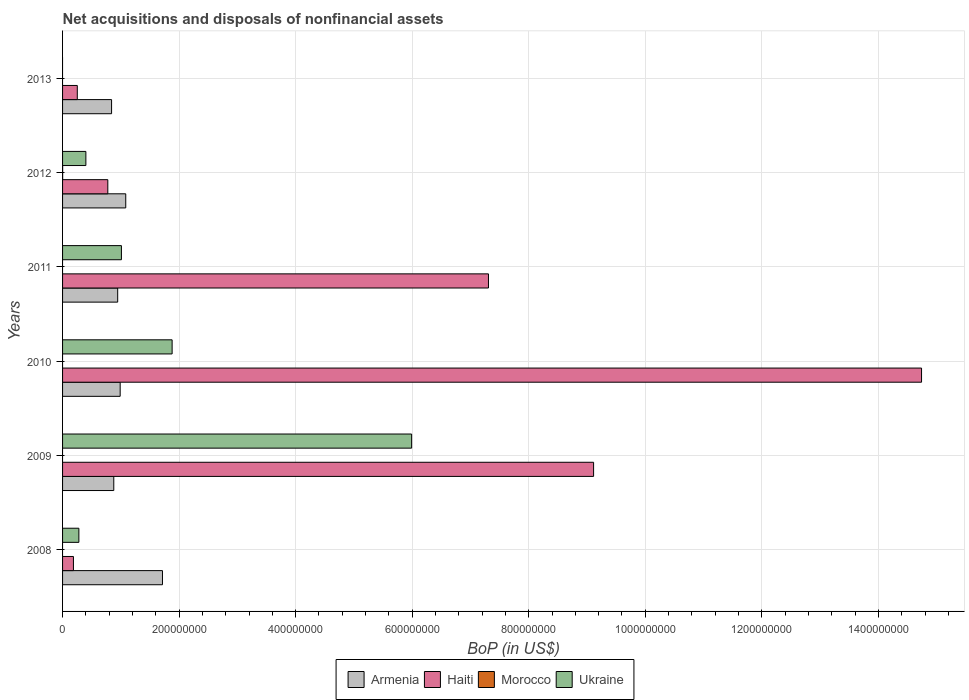Are the number of bars on each tick of the Y-axis equal?
Provide a short and direct response. No. What is the label of the 5th group of bars from the top?
Provide a succinct answer. 2009. What is the Balance of Payments in Haiti in 2012?
Your answer should be very brief. 7.77e+07. Across all years, what is the maximum Balance of Payments in Haiti?
Offer a terse response. 1.47e+09. Across all years, what is the minimum Balance of Payments in Armenia?
Offer a very short reply. 8.41e+07. In which year was the Balance of Payments in Armenia maximum?
Your answer should be compact. 2008. What is the total Balance of Payments in Ukraine in the graph?
Offer a very short reply. 9.56e+08. What is the difference between the Balance of Payments in Ukraine in 2008 and that in 2012?
Offer a very short reply. -1.20e+07. What is the difference between the Balance of Payments in Armenia in 2010 and the Balance of Payments in Ukraine in 2009?
Your response must be concise. -5.00e+08. What is the average Balance of Payments in Morocco per year?
Your answer should be compact. 2.14e+04. In the year 2008, what is the difference between the Balance of Payments in Haiti and Balance of Payments in Armenia?
Make the answer very short. -1.53e+08. What is the ratio of the Balance of Payments in Haiti in 2010 to that in 2012?
Make the answer very short. 18.98. Is the Balance of Payments in Haiti in 2011 less than that in 2013?
Offer a terse response. No. What is the difference between the highest and the second highest Balance of Payments in Haiti?
Ensure brevity in your answer.  5.63e+08. What is the difference between the highest and the lowest Balance of Payments in Morocco?
Your answer should be compact. 1.28e+05. In how many years, is the Balance of Payments in Ukraine greater than the average Balance of Payments in Ukraine taken over all years?
Ensure brevity in your answer.  2. Is the sum of the Balance of Payments in Ukraine in 2008 and 2012 greater than the maximum Balance of Payments in Morocco across all years?
Provide a short and direct response. Yes. Is it the case that in every year, the sum of the Balance of Payments in Haiti and Balance of Payments in Morocco is greater than the Balance of Payments in Ukraine?
Provide a succinct answer. No. Are all the bars in the graph horizontal?
Make the answer very short. Yes. Does the graph contain any zero values?
Your answer should be very brief. Yes. Where does the legend appear in the graph?
Your answer should be compact. Bottom center. How many legend labels are there?
Offer a terse response. 4. How are the legend labels stacked?
Keep it short and to the point. Horizontal. What is the title of the graph?
Offer a very short reply. Net acquisitions and disposals of nonfinancial assets. What is the label or title of the X-axis?
Provide a succinct answer. BoP (in US$). What is the BoP (in US$) of Armenia in 2008?
Your answer should be compact. 1.71e+08. What is the BoP (in US$) of Haiti in 2008?
Your answer should be very brief. 1.87e+07. What is the BoP (in US$) of Morocco in 2008?
Provide a succinct answer. 0. What is the BoP (in US$) of Ukraine in 2008?
Provide a succinct answer. 2.80e+07. What is the BoP (in US$) in Armenia in 2009?
Ensure brevity in your answer.  8.79e+07. What is the BoP (in US$) in Haiti in 2009?
Your response must be concise. 9.11e+08. What is the BoP (in US$) of Ukraine in 2009?
Your answer should be compact. 5.99e+08. What is the BoP (in US$) in Armenia in 2010?
Keep it short and to the point. 9.89e+07. What is the BoP (in US$) of Haiti in 2010?
Ensure brevity in your answer.  1.47e+09. What is the BoP (in US$) of Ukraine in 2010?
Provide a succinct answer. 1.88e+08. What is the BoP (in US$) in Armenia in 2011?
Your response must be concise. 9.46e+07. What is the BoP (in US$) of Haiti in 2011?
Make the answer very short. 7.31e+08. What is the BoP (in US$) in Ukraine in 2011?
Your response must be concise. 1.01e+08. What is the BoP (in US$) in Armenia in 2012?
Make the answer very short. 1.08e+08. What is the BoP (in US$) in Haiti in 2012?
Offer a terse response. 7.77e+07. What is the BoP (in US$) in Morocco in 2012?
Your answer should be very brief. 1.28e+05. What is the BoP (in US$) in Ukraine in 2012?
Give a very brief answer. 4.00e+07. What is the BoP (in US$) of Armenia in 2013?
Keep it short and to the point. 8.41e+07. What is the BoP (in US$) in Haiti in 2013?
Your response must be concise. 2.53e+07. Across all years, what is the maximum BoP (in US$) of Armenia?
Make the answer very short. 1.71e+08. Across all years, what is the maximum BoP (in US$) in Haiti?
Keep it short and to the point. 1.47e+09. Across all years, what is the maximum BoP (in US$) in Morocco?
Offer a very short reply. 1.28e+05. Across all years, what is the maximum BoP (in US$) in Ukraine?
Offer a terse response. 5.99e+08. Across all years, what is the minimum BoP (in US$) in Armenia?
Make the answer very short. 8.41e+07. Across all years, what is the minimum BoP (in US$) in Haiti?
Provide a short and direct response. 1.87e+07. Across all years, what is the minimum BoP (in US$) in Morocco?
Keep it short and to the point. 0. What is the total BoP (in US$) in Armenia in the graph?
Your answer should be compact. 6.45e+08. What is the total BoP (in US$) in Haiti in the graph?
Give a very brief answer. 3.24e+09. What is the total BoP (in US$) of Morocco in the graph?
Make the answer very short. 1.28e+05. What is the total BoP (in US$) of Ukraine in the graph?
Make the answer very short. 9.56e+08. What is the difference between the BoP (in US$) in Armenia in 2008 and that in 2009?
Provide a succinct answer. 8.36e+07. What is the difference between the BoP (in US$) in Haiti in 2008 and that in 2009?
Your answer should be very brief. -8.93e+08. What is the difference between the BoP (in US$) in Ukraine in 2008 and that in 2009?
Ensure brevity in your answer.  -5.71e+08. What is the difference between the BoP (in US$) of Armenia in 2008 and that in 2010?
Your answer should be very brief. 7.26e+07. What is the difference between the BoP (in US$) of Haiti in 2008 and that in 2010?
Keep it short and to the point. -1.46e+09. What is the difference between the BoP (in US$) in Ukraine in 2008 and that in 2010?
Give a very brief answer. -1.60e+08. What is the difference between the BoP (in US$) of Armenia in 2008 and that in 2011?
Keep it short and to the point. 7.68e+07. What is the difference between the BoP (in US$) in Haiti in 2008 and that in 2011?
Give a very brief answer. -7.12e+08. What is the difference between the BoP (in US$) of Ukraine in 2008 and that in 2011?
Offer a very short reply. -7.30e+07. What is the difference between the BoP (in US$) of Armenia in 2008 and that in 2012?
Provide a short and direct response. 6.30e+07. What is the difference between the BoP (in US$) in Haiti in 2008 and that in 2012?
Give a very brief answer. -5.90e+07. What is the difference between the BoP (in US$) in Ukraine in 2008 and that in 2012?
Make the answer very short. -1.20e+07. What is the difference between the BoP (in US$) of Armenia in 2008 and that in 2013?
Your response must be concise. 8.73e+07. What is the difference between the BoP (in US$) in Haiti in 2008 and that in 2013?
Keep it short and to the point. -6.62e+06. What is the difference between the BoP (in US$) of Armenia in 2009 and that in 2010?
Provide a succinct answer. -1.10e+07. What is the difference between the BoP (in US$) in Haiti in 2009 and that in 2010?
Offer a very short reply. -5.63e+08. What is the difference between the BoP (in US$) of Ukraine in 2009 and that in 2010?
Offer a terse response. 4.11e+08. What is the difference between the BoP (in US$) of Armenia in 2009 and that in 2011?
Make the answer very short. -6.72e+06. What is the difference between the BoP (in US$) in Haiti in 2009 and that in 2011?
Make the answer very short. 1.80e+08. What is the difference between the BoP (in US$) of Ukraine in 2009 and that in 2011?
Your response must be concise. 4.98e+08. What is the difference between the BoP (in US$) in Armenia in 2009 and that in 2012?
Offer a terse response. -2.05e+07. What is the difference between the BoP (in US$) of Haiti in 2009 and that in 2012?
Keep it short and to the point. 8.34e+08. What is the difference between the BoP (in US$) in Ukraine in 2009 and that in 2012?
Offer a very short reply. 5.59e+08. What is the difference between the BoP (in US$) in Armenia in 2009 and that in 2013?
Make the answer very short. 3.76e+06. What is the difference between the BoP (in US$) of Haiti in 2009 and that in 2013?
Ensure brevity in your answer.  8.86e+08. What is the difference between the BoP (in US$) of Armenia in 2010 and that in 2011?
Give a very brief answer. 4.26e+06. What is the difference between the BoP (in US$) of Haiti in 2010 and that in 2011?
Give a very brief answer. 7.43e+08. What is the difference between the BoP (in US$) in Ukraine in 2010 and that in 2011?
Offer a very short reply. 8.70e+07. What is the difference between the BoP (in US$) in Armenia in 2010 and that in 2012?
Offer a very short reply. -9.55e+06. What is the difference between the BoP (in US$) in Haiti in 2010 and that in 2012?
Keep it short and to the point. 1.40e+09. What is the difference between the BoP (in US$) of Ukraine in 2010 and that in 2012?
Give a very brief answer. 1.48e+08. What is the difference between the BoP (in US$) of Armenia in 2010 and that in 2013?
Make the answer very short. 1.47e+07. What is the difference between the BoP (in US$) in Haiti in 2010 and that in 2013?
Provide a succinct answer. 1.45e+09. What is the difference between the BoP (in US$) of Armenia in 2011 and that in 2012?
Ensure brevity in your answer.  -1.38e+07. What is the difference between the BoP (in US$) of Haiti in 2011 and that in 2012?
Make the answer very short. 6.53e+08. What is the difference between the BoP (in US$) of Ukraine in 2011 and that in 2012?
Your response must be concise. 6.10e+07. What is the difference between the BoP (in US$) in Armenia in 2011 and that in 2013?
Provide a short and direct response. 1.05e+07. What is the difference between the BoP (in US$) in Haiti in 2011 and that in 2013?
Provide a short and direct response. 7.06e+08. What is the difference between the BoP (in US$) of Armenia in 2012 and that in 2013?
Give a very brief answer. 2.43e+07. What is the difference between the BoP (in US$) in Haiti in 2012 and that in 2013?
Your response must be concise. 5.24e+07. What is the difference between the BoP (in US$) of Armenia in 2008 and the BoP (in US$) of Haiti in 2009?
Provide a succinct answer. -7.40e+08. What is the difference between the BoP (in US$) of Armenia in 2008 and the BoP (in US$) of Ukraine in 2009?
Provide a succinct answer. -4.28e+08. What is the difference between the BoP (in US$) of Haiti in 2008 and the BoP (in US$) of Ukraine in 2009?
Offer a terse response. -5.80e+08. What is the difference between the BoP (in US$) in Armenia in 2008 and the BoP (in US$) in Haiti in 2010?
Your response must be concise. -1.30e+09. What is the difference between the BoP (in US$) in Armenia in 2008 and the BoP (in US$) in Ukraine in 2010?
Give a very brief answer. -1.66e+07. What is the difference between the BoP (in US$) in Haiti in 2008 and the BoP (in US$) in Ukraine in 2010?
Offer a terse response. -1.69e+08. What is the difference between the BoP (in US$) in Armenia in 2008 and the BoP (in US$) in Haiti in 2011?
Give a very brief answer. -5.59e+08. What is the difference between the BoP (in US$) in Armenia in 2008 and the BoP (in US$) in Ukraine in 2011?
Your answer should be very brief. 7.04e+07. What is the difference between the BoP (in US$) of Haiti in 2008 and the BoP (in US$) of Ukraine in 2011?
Your answer should be compact. -8.23e+07. What is the difference between the BoP (in US$) in Armenia in 2008 and the BoP (in US$) in Haiti in 2012?
Ensure brevity in your answer.  9.38e+07. What is the difference between the BoP (in US$) of Armenia in 2008 and the BoP (in US$) of Morocco in 2012?
Keep it short and to the point. 1.71e+08. What is the difference between the BoP (in US$) in Armenia in 2008 and the BoP (in US$) in Ukraine in 2012?
Your response must be concise. 1.31e+08. What is the difference between the BoP (in US$) of Haiti in 2008 and the BoP (in US$) of Morocco in 2012?
Ensure brevity in your answer.  1.85e+07. What is the difference between the BoP (in US$) of Haiti in 2008 and the BoP (in US$) of Ukraine in 2012?
Your response must be concise. -2.13e+07. What is the difference between the BoP (in US$) of Armenia in 2008 and the BoP (in US$) of Haiti in 2013?
Offer a very short reply. 1.46e+08. What is the difference between the BoP (in US$) in Armenia in 2009 and the BoP (in US$) in Haiti in 2010?
Provide a short and direct response. -1.39e+09. What is the difference between the BoP (in US$) in Armenia in 2009 and the BoP (in US$) in Ukraine in 2010?
Offer a terse response. -1.00e+08. What is the difference between the BoP (in US$) of Haiti in 2009 and the BoP (in US$) of Ukraine in 2010?
Make the answer very short. 7.23e+08. What is the difference between the BoP (in US$) of Armenia in 2009 and the BoP (in US$) of Haiti in 2011?
Keep it short and to the point. -6.43e+08. What is the difference between the BoP (in US$) of Armenia in 2009 and the BoP (in US$) of Ukraine in 2011?
Offer a terse response. -1.31e+07. What is the difference between the BoP (in US$) of Haiti in 2009 and the BoP (in US$) of Ukraine in 2011?
Your answer should be very brief. 8.10e+08. What is the difference between the BoP (in US$) in Armenia in 2009 and the BoP (in US$) in Haiti in 2012?
Ensure brevity in your answer.  1.02e+07. What is the difference between the BoP (in US$) in Armenia in 2009 and the BoP (in US$) in Morocco in 2012?
Your answer should be very brief. 8.78e+07. What is the difference between the BoP (in US$) in Armenia in 2009 and the BoP (in US$) in Ukraine in 2012?
Your answer should be very brief. 4.79e+07. What is the difference between the BoP (in US$) of Haiti in 2009 and the BoP (in US$) of Morocco in 2012?
Keep it short and to the point. 9.11e+08. What is the difference between the BoP (in US$) of Haiti in 2009 and the BoP (in US$) of Ukraine in 2012?
Your answer should be very brief. 8.71e+08. What is the difference between the BoP (in US$) of Armenia in 2009 and the BoP (in US$) of Haiti in 2013?
Your answer should be very brief. 6.26e+07. What is the difference between the BoP (in US$) in Armenia in 2010 and the BoP (in US$) in Haiti in 2011?
Ensure brevity in your answer.  -6.32e+08. What is the difference between the BoP (in US$) of Armenia in 2010 and the BoP (in US$) of Ukraine in 2011?
Ensure brevity in your answer.  -2.14e+06. What is the difference between the BoP (in US$) in Haiti in 2010 and the BoP (in US$) in Ukraine in 2011?
Offer a very short reply. 1.37e+09. What is the difference between the BoP (in US$) in Armenia in 2010 and the BoP (in US$) in Haiti in 2012?
Keep it short and to the point. 2.12e+07. What is the difference between the BoP (in US$) of Armenia in 2010 and the BoP (in US$) of Morocco in 2012?
Offer a very short reply. 9.87e+07. What is the difference between the BoP (in US$) of Armenia in 2010 and the BoP (in US$) of Ukraine in 2012?
Offer a very short reply. 5.89e+07. What is the difference between the BoP (in US$) in Haiti in 2010 and the BoP (in US$) in Morocco in 2012?
Your response must be concise. 1.47e+09. What is the difference between the BoP (in US$) of Haiti in 2010 and the BoP (in US$) of Ukraine in 2012?
Provide a short and direct response. 1.43e+09. What is the difference between the BoP (in US$) in Armenia in 2010 and the BoP (in US$) in Haiti in 2013?
Offer a very short reply. 7.36e+07. What is the difference between the BoP (in US$) in Armenia in 2011 and the BoP (in US$) in Haiti in 2012?
Give a very brief answer. 1.69e+07. What is the difference between the BoP (in US$) of Armenia in 2011 and the BoP (in US$) of Morocco in 2012?
Make the answer very short. 9.45e+07. What is the difference between the BoP (in US$) of Armenia in 2011 and the BoP (in US$) of Ukraine in 2012?
Give a very brief answer. 5.46e+07. What is the difference between the BoP (in US$) in Haiti in 2011 and the BoP (in US$) in Morocco in 2012?
Your answer should be very brief. 7.31e+08. What is the difference between the BoP (in US$) of Haiti in 2011 and the BoP (in US$) of Ukraine in 2012?
Offer a very short reply. 6.91e+08. What is the difference between the BoP (in US$) of Armenia in 2011 and the BoP (in US$) of Haiti in 2013?
Ensure brevity in your answer.  6.93e+07. What is the difference between the BoP (in US$) in Armenia in 2012 and the BoP (in US$) in Haiti in 2013?
Make the answer very short. 8.31e+07. What is the average BoP (in US$) of Armenia per year?
Offer a terse response. 1.08e+08. What is the average BoP (in US$) in Haiti per year?
Ensure brevity in your answer.  5.40e+08. What is the average BoP (in US$) of Morocco per year?
Keep it short and to the point. 2.14e+04. What is the average BoP (in US$) in Ukraine per year?
Provide a short and direct response. 1.59e+08. In the year 2008, what is the difference between the BoP (in US$) of Armenia and BoP (in US$) of Haiti?
Offer a very short reply. 1.53e+08. In the year 2008, what is the difference between the BoP (in US$) in Armenia and BoP (in US$) in Ukraine?
Keep it short and to the point. 1.43e+08. In the year 2008, what is the difference between the BoP (in US$) in Haiti and BoP (in US$) in Ukraine?
Offer a very short reply. -9.34e+06. In the year 2009, what is the difference between the BoP (in US$) of Armenia and BoP (in US$) of Haiti?
Give a very brief answer. -8.23e+08. In the year 2009, what is the difference between the BoP (in US$) of Armenia and BoP (in US$) of Ukraine?
Keep it short and to the point. -5.11e+08. In the year 2009, what is the difference between the BoP (in US$) in Haiti and BoP (in US$) in Ukraine?
Offer a very short reply. 3.12e+08. In the year 2010, what is the difference between the BoP (in US$) in Armenia and BoP (in US$) in Haiti?
Give a very brief answer. -1.38e+09. In the year 2010, what is the difference between the BoP (in US$) of Armenia and BoP (in US$) of Ukraine?
Make the answer very short. -8.91e+07. In the year 2010, what is the difference between the BoP (in US$) of Haiti and BoP (in US$) of Ukraine?
Your answer should be very brief. 1.29e+09. In the year 2011, what is the difference between the BoP (in US$) of Armenia and BoP (in US$) of Haiti?
Offer a very short reply. -6.36e+08. In the year 2011, what is the difference between the BoP (in US$) in Armenia and BoP (in US$) in Ukraine?
Provide a succinct answer. -6.40e+06. In the year 2011, what is the difference between the BoP (in US$) of Haiti and BoP (in US$) of Ukraine?
Your response must be concise. 6.30e+08. In the year 2012, what is the difference between the BoP (in US$) of Armenia and BoP (in US$) of Haiti?
Keep it short and to the point. 3.08e+07. In the year 2012, what is the difference between the BoP (in US$) in Armenia and BoP (in US$) in Morocco?
Your answer should be very brief. 1.08e+08. In the year 2012, what is the difference between the BoP (in US$) in Armenia and BoP (in US$) in Ukraine?
Provide a short and direct response. 6.84e+07. In the year 2012, what is the difference between the BoP (in US$) in Haiti and BoP (in US$) in Morocco?
Offer a very short reply. 7.75e+07. In the year 2012, what is the difference between the BoP (in US$) of Haiti and BoP (in US$) of Ukraine?
Make the answer very short. 3.77e+07. In the year 2012, what is the difference between the BoP (in US$) in Morocco and BoP (in US$) in Ukraine?
Keep it short and to the point. -3.99e+07. In the year 2013, what is the difference between the BoP (in US$) in Armenia and BoP (in US$) in Haiti?
Provide a succinct answer. 5.88e+07. What is the ratio of the BoP (in US$) of Armenia in 2008 to that in 2009?
Ensure brevity in your answer.  1.95. What is the ratio of the BoP (in US$) in Haiti in 2008 to that in 2009?
Provide a succinct answer. 0.02. What is the ratio of the BoP (in US$) in Ukraine in 2008 to that in 2009?
Ensure brevity in your answer.  0.05. What is the ratio of the BoP (in US$) of Armenia in 2008 to that in 2010?
Provide a short and direct response. 1.73. What is the ratio of the BoP (in US$) in Haiti in 2008 to that in 2010?
Make the answer very short. 0.01. What is the ratio of the BoP (in US$) in Ukraine in 2008 to that in 2010?
Provide a succinct answer. 0.15. What is the ratio of the BoP (in US$) in Armenia in 2008 to that in 2011?
Your response must be concise. 1.81. What is the ratio of the BoP (in US$) of Haiti in 2008 to that in 2011?
Offer a terse response. 0.03. What is the ratio of the BoP (in US$) of Ukraine in 2008 to that in 2011?
Give a very brief answer. 0.28. What is the ratio of the BoP (in US$) in Armenia in 2008 to that in 2012?
Ensure brevity in your answer.  1.58. What is the ratio of the BoP (in US$) in Haiti in 2008 to that in 2012?
Your response must be concise. 0.24. What is the ratio of the BoP (in US$) of Armenia in 2008 to that in 2013?
Offer a terse response. 2.04. What is the ratio of the BoP (in US$) in Haiti in 2008 to that in 2013?
Offer a terse response. 0.74. What is the ratio of the BoP (in US$) of Haiti in 2009 to that in 2010?
Your answer should be compact. 0.62. What is the ratio of the BoP (in US$) of Ukraine in 2009 to that in 2010?
Your response must be concise. 3.19. What is the ratio of the BoP (in US$) of Armenia in 2009 to that in 2011?
Provide a short and direct response. 0.93. What is the ratio of the BoP (in US$) in Haiti in 2009 to that in 2011?
Ensure brevity in your answer.  1.25. What is the ratio of the BoP (in US$) of Ukraine in 2009 to that in 2011?
Your response must be concise. 5.93. What is the ratio of the BoP (in US$) in Armenia in 2009 to that in 2012?
Offer a terse response. 0.81. What is the ratio of the BoP (in US$) in Haiti in 2009 to that in 2012?
Offer a very short reply. 11.74. What is the ratio of the BoP (in US$) of Ukraine in 2009 to that in 2012?
Make the answer very short. 14.97. What is the ratio of the BoP (in US$) in Armenia in 2009 to that in 2013?
Offer a very short reply. 1.04. What is the ratio of the BoP (in US$) of Haiti in 2009 to that in 2013?
Provide a short and direct response. 36.04. What is the ratio of the BoP (in US$) of Armenia in 2010 to that in 2011?
Your answer should be compact. 1.04. What is the ratio of the BoP (in US$) of Haiti in 2010 to that in 2011?
Your answer should be compact. 2.02. What is the ratio of the BoP (in US$) of Ukraine in 2010 to that in 2011?
Offer a very short reply. 1.86. What is the ratio of the BoP (in US$) in Armenia in 2010 to that in 2012?
Ensure brevity in your answer.  0.91. What is the ratio of the BoP (in US$) in Haiti in 2010 to that in 2012?
Make the answer very short. 18.98. What is the ratio of the BoP (in US$) in Ukraine in 2010 to that in 2012?
Make the answer very short. 4.7. What is the ratio of the BoP (in US$) in Armenia in 2010 to that in 2013?
Provide a short and direct response. 1.18. What is the ratio of the BoP (in US$) in Haiti in 2010 to that in 2013?
Provide a short and direct response. 58.3. What is the ratio of the BoP (in US$) of Armenia in 2011 to that in 2012?
Offer a very short reply. 0.87. What is the ratio of the BoP (in US$) of Haiti in 2011 to that in 2012?
Your response must be concise. 9.41. What is the ratio of the BoP (in US$) of Ukraine in 2011 to that in 2012?
Your answer should be compact. 2.52. What is the ratio of the BoP (in US$) of Armenia in 2011 to that in 2013?
Offer a very short reply. 1.12. What is the ratio of the BoP (in US$) of Haiti in 2011 to that in 2013?
Make the answer very short. 28.9. What is the ratio of the BoP (in US$) of Armenia in 2012 to that in 2013?
Ensure brevity in your answer.  1.29. What is the ratio of the BoP (in US$) in Haiti in 2012 to that in 2013?
Offer a terse response. 3.07. What is the difference between the highest and the second highest BoP (in US$) of Armenia?
Offer a terse response. 6.30e+07. What is the difference between the highest and the second highest BoP (in US$) in Haiti?
Your answer should be compact. 5.63e+08. What is the difference between the highest and the second highest BoP (in US$) in Ukraine?
Make the answer very short. 4.11e+08. What is the difference between the highest and the lowest BoP (in US$) of Armenia?
Provide a short and direct response. 8.73e+07. What is the difference between the highest and the lowest BoP (in US$) of Haiti?
Give a very brief answer. 1.46e+09. What is the difference between the highest and the lowest BoP (in US$) in Morocco?
Your response must be concise. 1.28e+05. What is the difference between the highest and the lowest BoP (in US$) in Ukraine?
Offer a very short reply. 5.99e+08. 